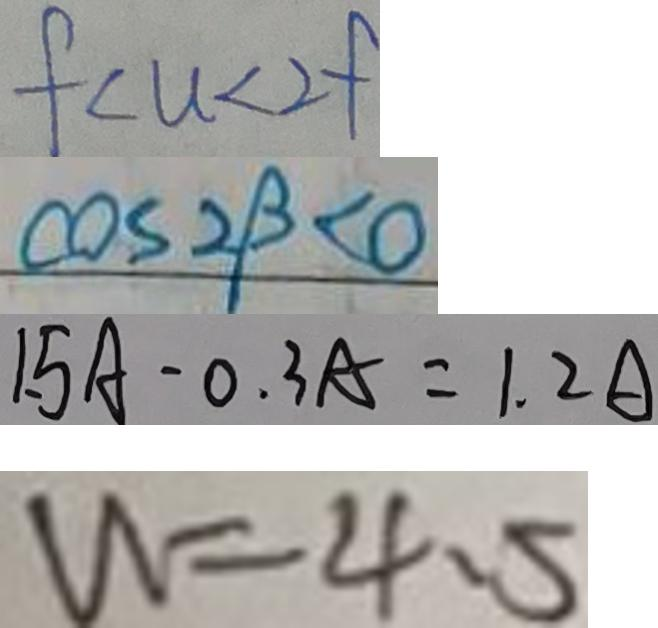Convert formula to latex. <formula><loc_0><loc_0><loc_500><loc_500>f < u < 2 f 
 \cos 2 \beta < 0 
 1 . 5 A - 0 . 3 A = 1 . 2 A 
 W = 4 . 5</formula> 